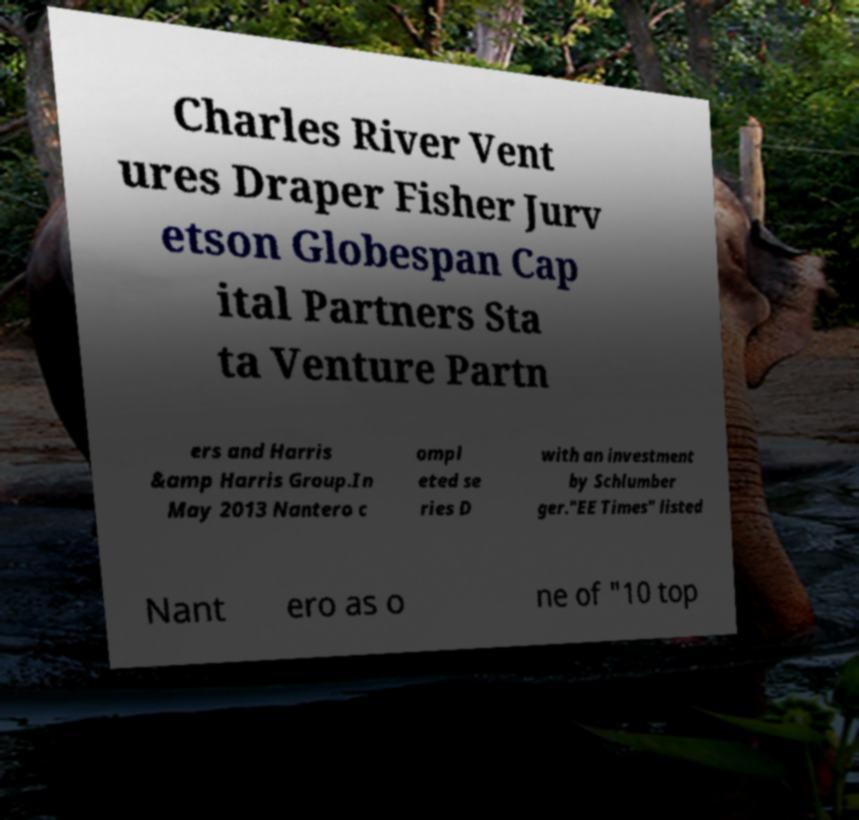For documentation purposes, I need the text within this image transcribed. Could you provide that? Charles River Vent ures Draper Fisher Jurv etson Globespan Cap ital Partners Sta ta Venture Partn ers and Harris &amp Harris Group.In May 2013 Nantero c ompl eted se ries D with an investment by Schlumber ger."EE Times" listed Nant ero as o ne of "10 top 